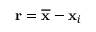<formula> <loc_0><loc_0><loc_500><loc_500>\mathbf r = \overline { \mathbf x } - \mathbf x _ { i }</formula> 